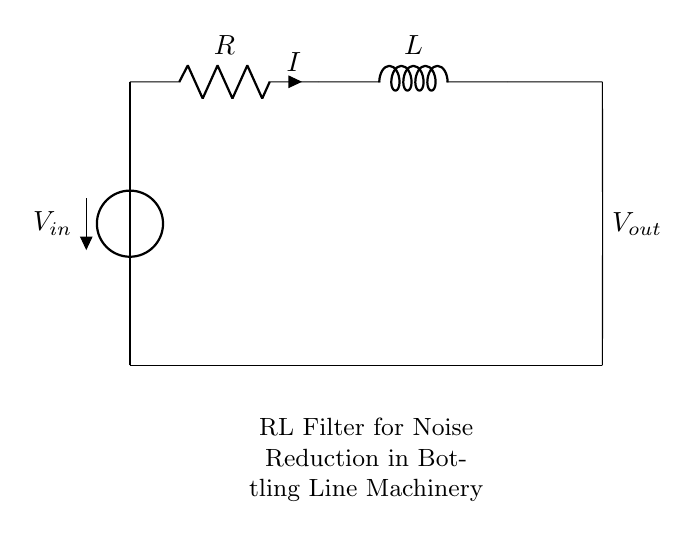What is the input voltage in this circuit? The input voltage is represented by the voltage source labeled V in the circuit. The label indicates that there is an applied voltage to the circuit.
Answer: V What component is in series with the resistor? The component in series with the resistor is the inductor, as shown in the circuit diagram where the resistor is connected directly to the inductor.
Answer: Inductor What is the current flowing through the resistor? The current flowing through the resistor is denoted by the label i in the diagram. Since it is in series with the inductor, the same current goes through both components.
Answer: i What type of filter is this circuit? This circuit is a low-pass filter, as it uses a resistor and inductor to attenuate high-frequency noise while allowing lower frequencies to pass.
Answer: Low-pass filter How many passive components are present in this circuit? There are two passive components in this circuit: one resistor and one inductor. Passive components do not provide gain or power to the circuit, and the circuit clearly shows both.
Answer: Two What is the purpose of this circuit in relation to machinery? The purpose of this circuit is to reduce noise in bottling line machinery. The combination of the resistor and inductor helps filter out unwanted high-frequency signals.
Answer: Noise reduction 